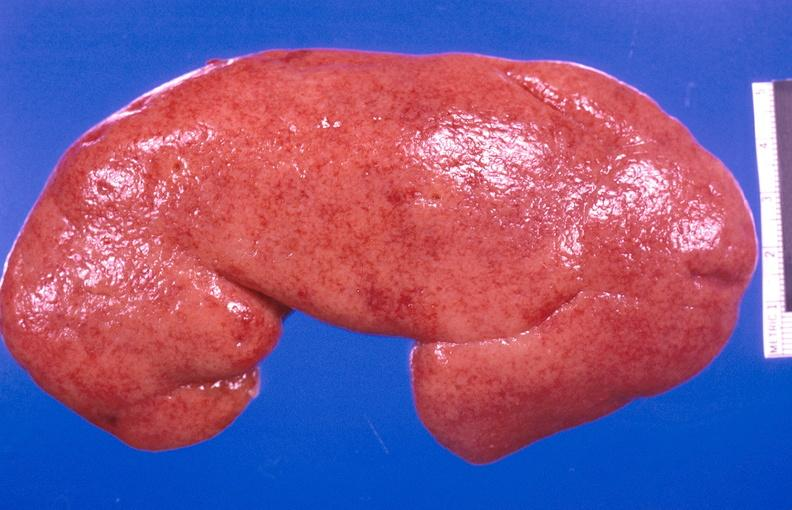does % show kidney aspergillosis?
Answer the question using a single word or phrase. No 